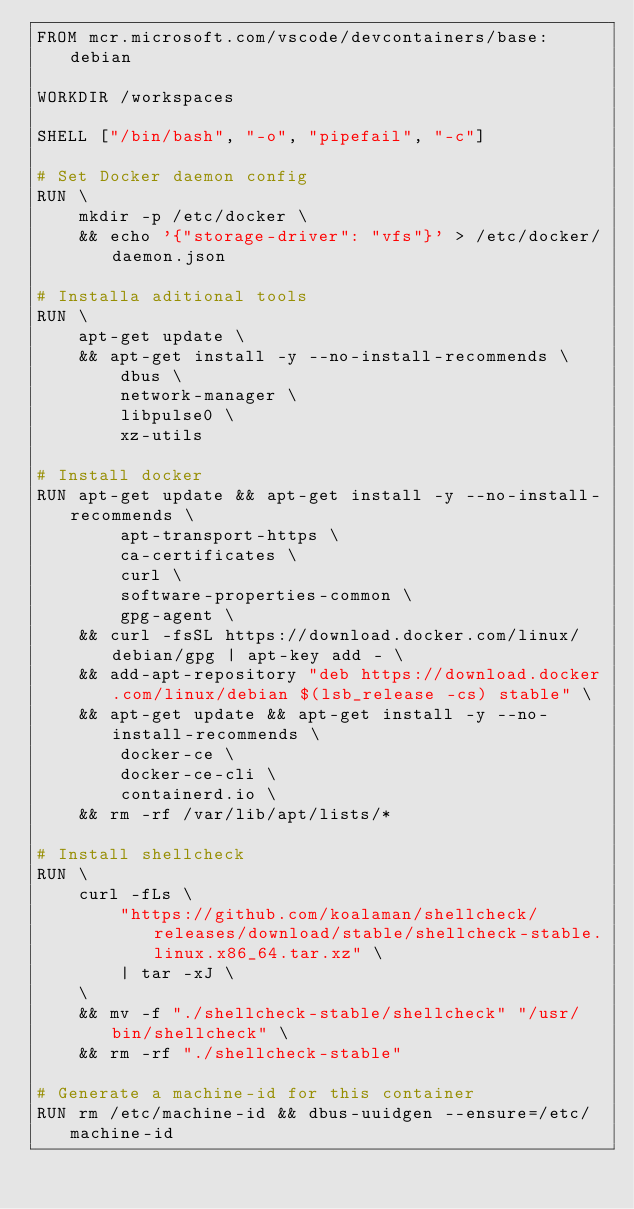Convert code to text. <code><loc_0><loc_0><loc_500><loc_500><_Dockerfile_>FROM mcr.microsoft.com/vscode/devcontainers/base:debian

WORKDIR /workspaces

SHELL ["/bin/bash", "-o", "pipefail", "-c"]

# Set Docker daemon config
RUN \
    mkdir -p /etc/docker \
    && echo '{"storage-driver": "vfs"}' > /etc/docker/daemon.json

# Installa aditional tools
RUN \
    apt-get update \
    && apt-get install -y --no-install-recommends \
        dbus \
        network-manager \
        libpulse0 \
        xz-utils

# Install docker
RUN apt-get update && apt-get install -y --no-install-recommends \
        apt-transport-https \
        ca-certificates \
        curl \
        software-properties-common \
        gpg-agent \
    && curl -fsSL https://download.docker.com/linux/debian/gpg | apt-key add - \
    && add-apt-repository "deb https://download.docker.com/linux/debian $(lsb_release -cs) stable" \
    && apt-get update && apt-get install -y --no-install-recommends \
        docker-ce \
        docker-ce-cli \
        containerd.io \
    && rm -rf /var/lib/apt/lists/*

# Install shellcheck
RUN \
    curl -fLs \
        "https://github.com/koalaman/shellcheck/releases/download/stable/shellcheck-stable.linux.x86_64.tar.xz" \
        | tar -xJ \
    \
    && mv -f "./shellcheck-stable/shellcheck" "/usr/bin/shellcheck" \
    && rm -rf "./shellcheck-stable"

# Generate a machine-id for this container
RUN rm /etc/machine-id && dbus-uuidgen --ensure=/etc/machine-id
</code> 